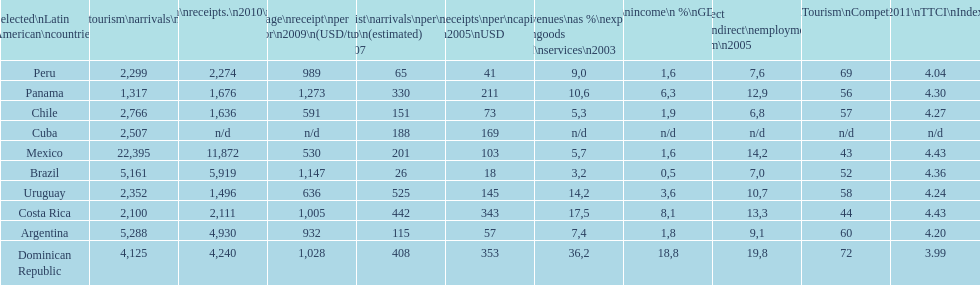Which latin american country had the largest number of tourism arrivals in 2010? Mexico. 